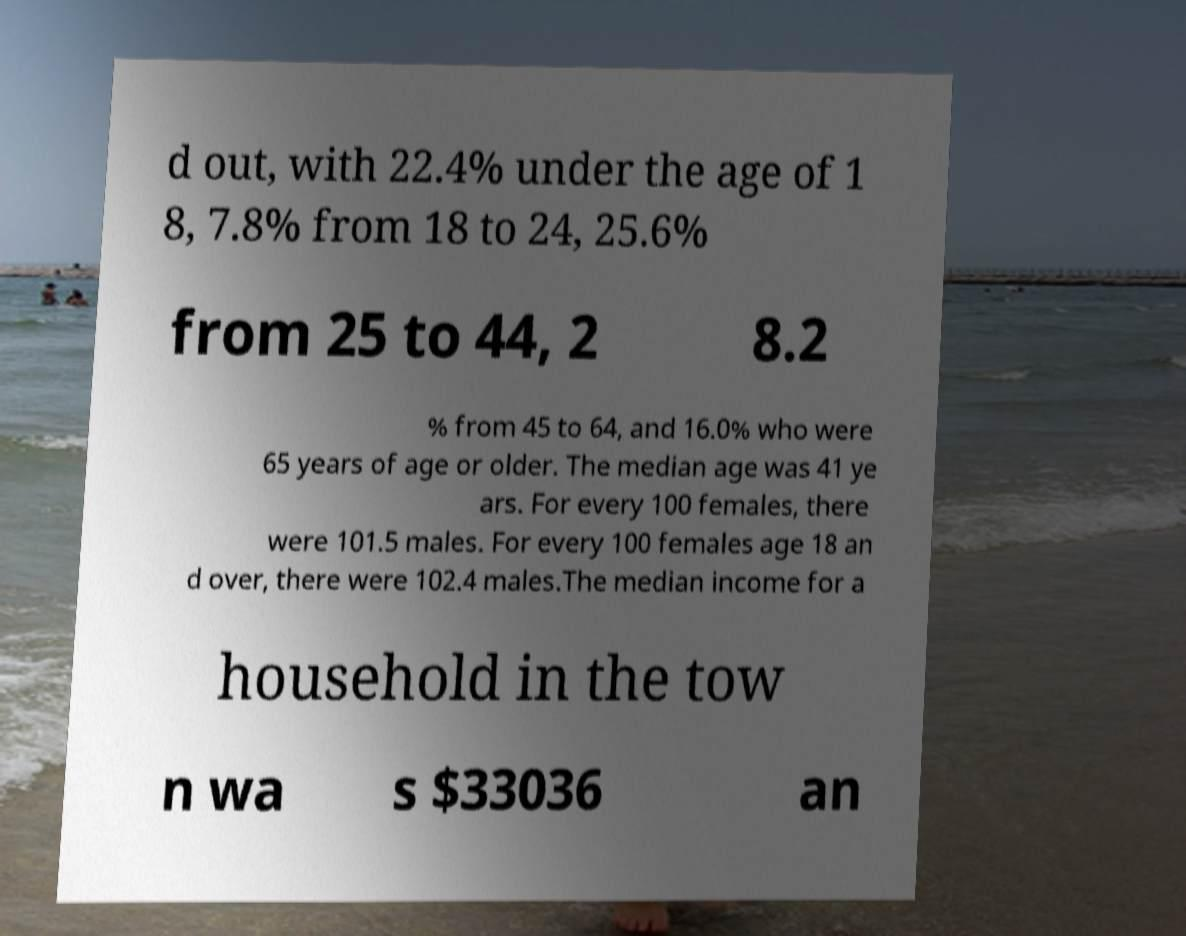Could you extract and type out the text from this image? d out, with 22.4% under the age of 1 8, 7.8% from 18 to 24, 25.6% from 25 to 44, 2 8.2 % from 45 to 64, and 16.0% who were 65 years of age or older. The median age was 41 ye ars. For every 100 females, there were 101.5 males. For every 100 females age 18 an d over, there were 102.4 males.The median income for a household in the tow n wa s $33036 an 